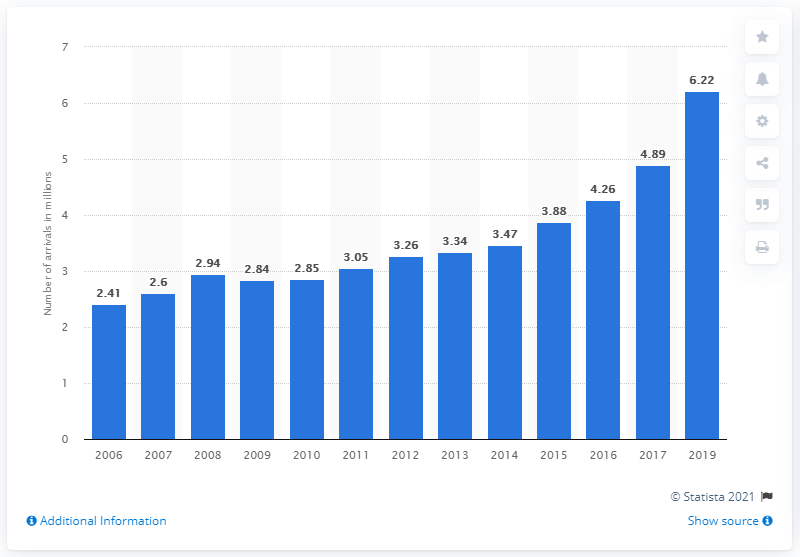Outline some significant characteristics in this image. In 2019, there were 6,220 tourist arrivals at accommodation establishments in Slovenia. 